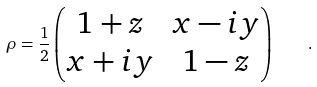<formula> <loc_0><loc_0><loc_500><loc_500>\rho = { \frac { 1 } { 2 } } \begin{pmatrix} 1 + z & x - i y \\ x + i y & 1 - z \end{pmatrix} \quad .</formula> 